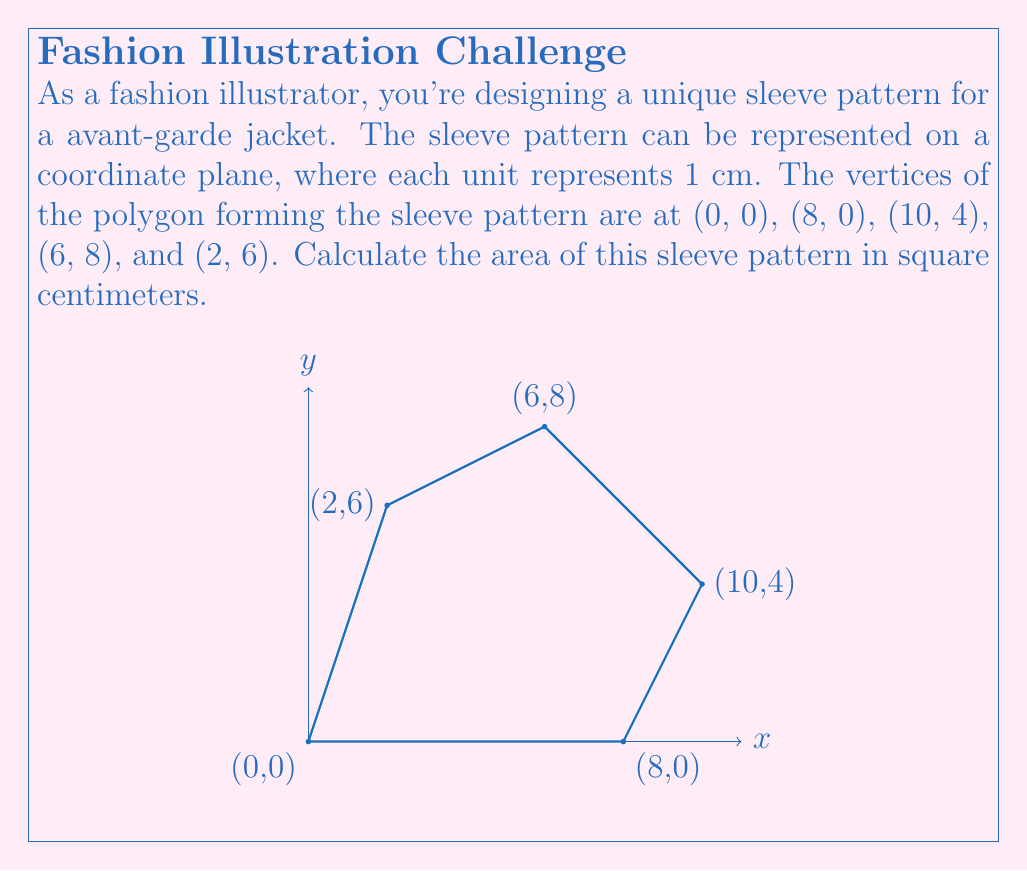Can you solve this math problem? To find the area of this irregular polygon, we can use the Shoelace formula (also known as the surveyor's formula). This method involves calculating the sum of the cross products of the coordinates.

The formula for the area is:

$$ A = \frac{1}{2}\left|\sum_{i=1}^{n} (x_i y_{i+1} - x_{i+1} y_i)\right| $$

Where $(x_i, y_i)$ are the coordinates of the $i$-th vertex, and $(x_{n+1}, y_{n+1}) = (x_1, y_1)$.

Let's apply this formula to our polygon:

1) First, let's list our vertices in order:
   $(0,0)$, $(8,0)$, $(10,4)$, $(6,8)$, $(2,6)$, and back to $(0,0)$

2) Now, let's calculate each term of the sum:
   
   $0 \cdot 0 - 8 \cdot 0 = 0$
   $8 \cdot 4 - 10 \cdot 0 = 32$
   $10 \cdot 8 - 6 \cdot 4 = 56$
   $6 \cdot 6 - 2 \cdot 8 = 20$
   $2 \cdot 0 - 0 \cdot 6 = 0$

3) Sum these values:
   $0 + 32 + 56 + 20 + 0 = 108$

4) Take the absolute value and divide by 2:
   $\frac{1}{2}|108| = 54$

Therefore, the area of the sleeve pattern is 54 square centimeters.
Answer: $54 \text{ cm}^2$ 